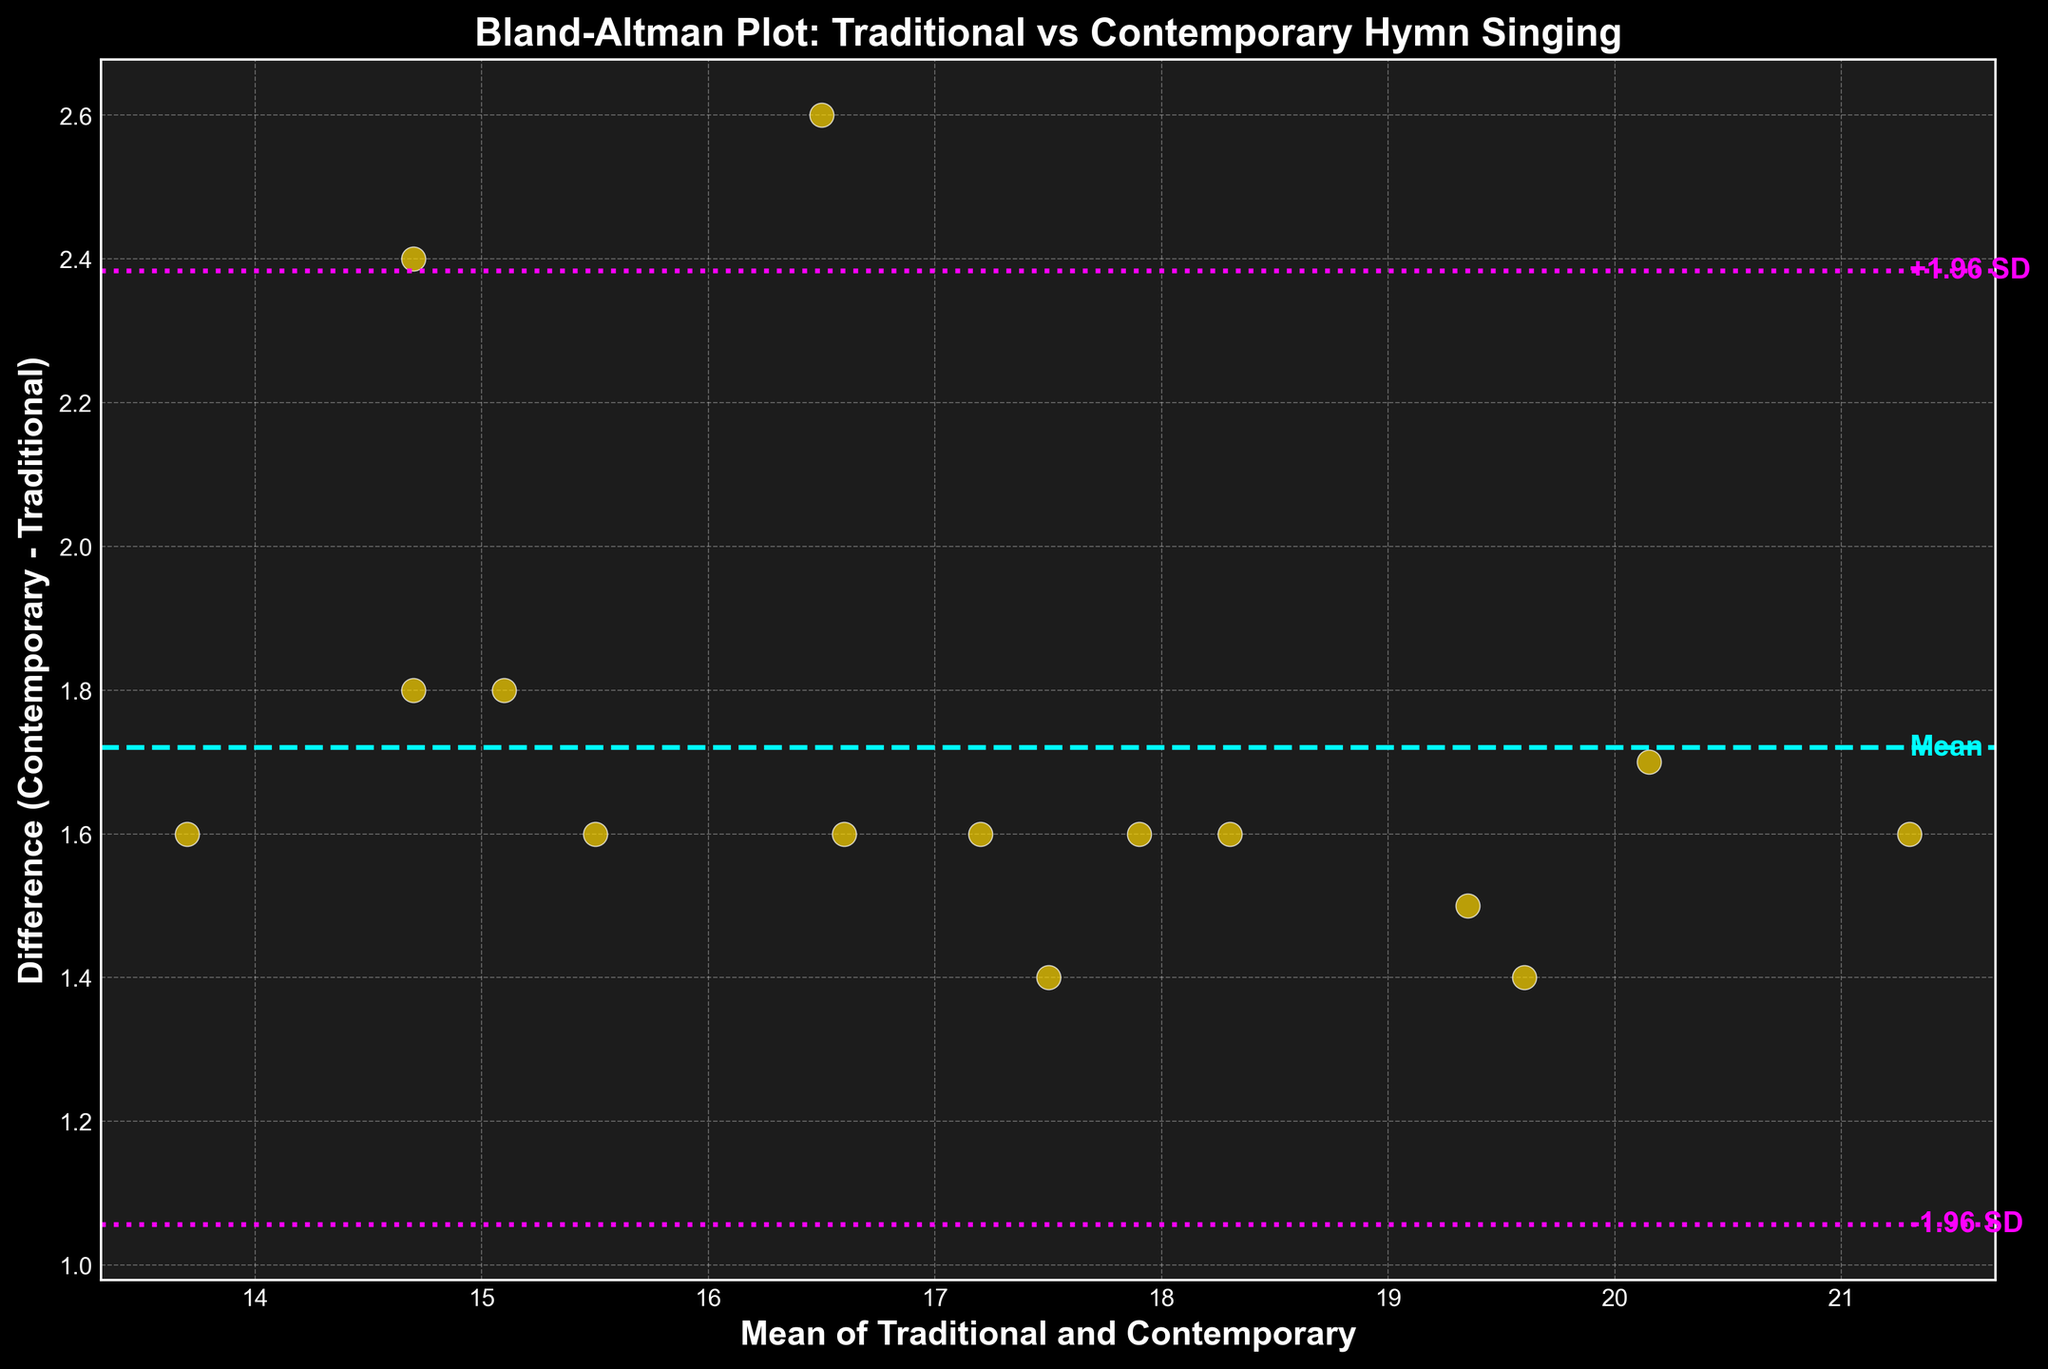How many data points are shown in the Bland-Altman plot? Count the number of points (gold dots) plotted on the figure. Each point represents a data pair.
Answer: 15 What color is used for the mean difference line in the plot? Observe the line color of the horizontal line marked as "Mean" which runs through the middle of the set of points.
Answer: Cyan What are the limits of agreement displayed in the plot? Identify the lines marked as "-1.96 SD" and "+1.96 SD" on the figure. These values represent the lower and upper limits of agreement.
Answer: -1.14, 3.02 What is the mean difference between contemporary and traditional hymns? Look for the value associated with the horizontal line labeled "Mean."
Answer: 0.94 What is the maximum value on the x-axis? Locate the far-right end of the x-axis to find the maximum mean value of the traditional and contemporary measurements.
Answer: 21.3 How many data points fall outside the limits of agreement? Count the points that lie above the "+1.96 SD" line and below the "-1.96 SD" line.
Answer: 0 Between which two values does the majority of the data points' differences lie? Observe where most gold dots are clustered and take note of the value range on the y-axis where they fall.
Answer: -0.5, 2 What does the vertical axis represent in this plot? Refer to the label of the vertical axis to determine what it measures.
Answer: Difference (Contemporary - Traditional) How does the mean difference compare to the limit of agreement lines? Compare the horizontal line marking the mean difference to the upper and lower horizontal lines marking the limits of agreement.
Answer: The mean difference is between the limits Why are the lines for limits of agreement significant in this Bland-Altman plot? Understand the concept of limits of agreement, which show the range within which most differences should lie. These lines help identify any outliers or trends in consistency.
Answer: They indicate the range where most differences fall, showing consistency 